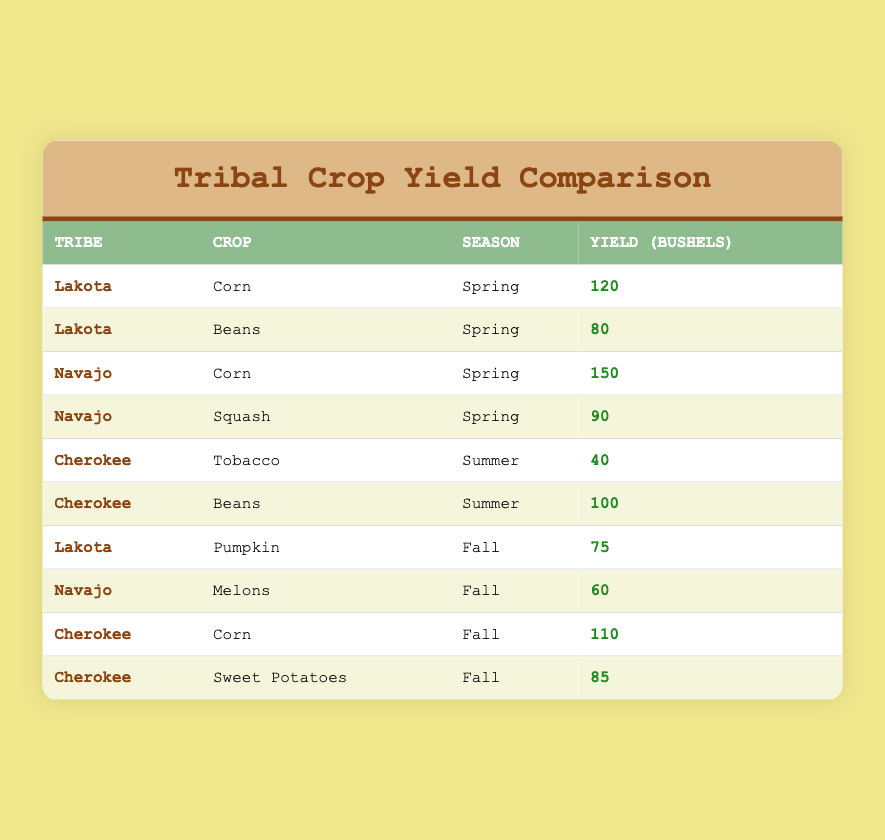What crop yielded the highest amount in Spring? From the table, I can see two crops grown in Spring: Corn (120 bushels from the Lakota tribe) and Corn (150 bushels from the Navajo tribe). The Navajo produced more Corn than the Lakota, making it the highest yield.
Answer: Corn (Navajo): 150 bushels Which tribe produced Sweet Potatoes and in which season? Looking at the table, I find that the Cherokee tribe grew Sweet Potatoes in the Fall season as listed in the row corresponding to that crop.
Answer: Cherokee in Fall What is the total yield of all crops produced by the Lakota? The Lakota tribe produced Corn (120), Beans (80), and Pumpkin (75). Adding these yields gives a total of 120 + 80 + 75 = 275 bushels.
Answer: 275 bushels Did the Cherokee tribe produce any crops in Spring? The table shows that the Cherokee tribe did not have any crops listed for the Spring season; they only have crops in Summer and Fall.
Answer: No Which tribe has the highest combined yield across all seasons for their crops? To find this, I need to add up the yields for each tribe: Lakota: 120 + 80 + 75 = 275; Navajo: 150 + 90 + 60 = 300; Cherokee: 40 + 100 + 110 + 85 = 335. The Cherokee tribe has the highest total yield.
Answer: Cherokee: 335 bushels 